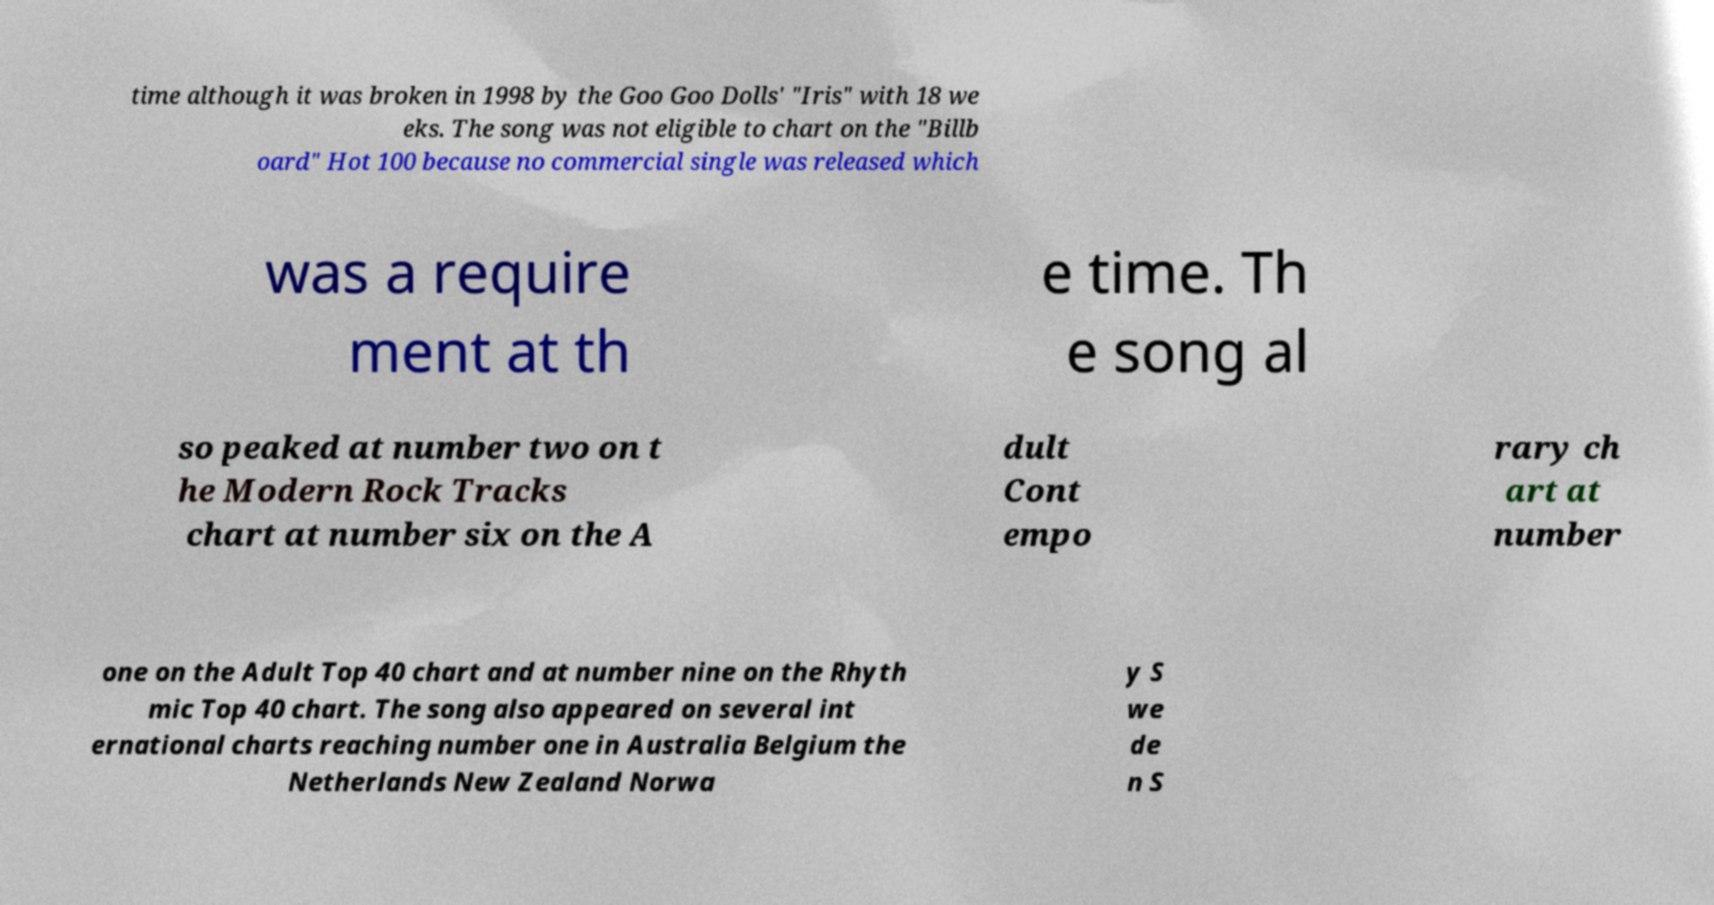Could you extract and type out the text from this image? time although it was broken in 1998 by the Goo Goo Dolls' "Iris" with 18 we eks. The song was not eligible to chart on the "Billb oard" Hot 100 because no commercial single was released which was a require ment at th e time. Th e song al so peaked at number two on t he Modern Rock Tracks chart at number six on the A dult Cont empo rary ch art at number one on the Adult Top 40 chart and at number nine on the Rhyth mic Top 40 chart. The song also appeared on several int ernational charts reaching number one in Australia Belgium the Netherlands New Zealand Norwa y S we de n S 